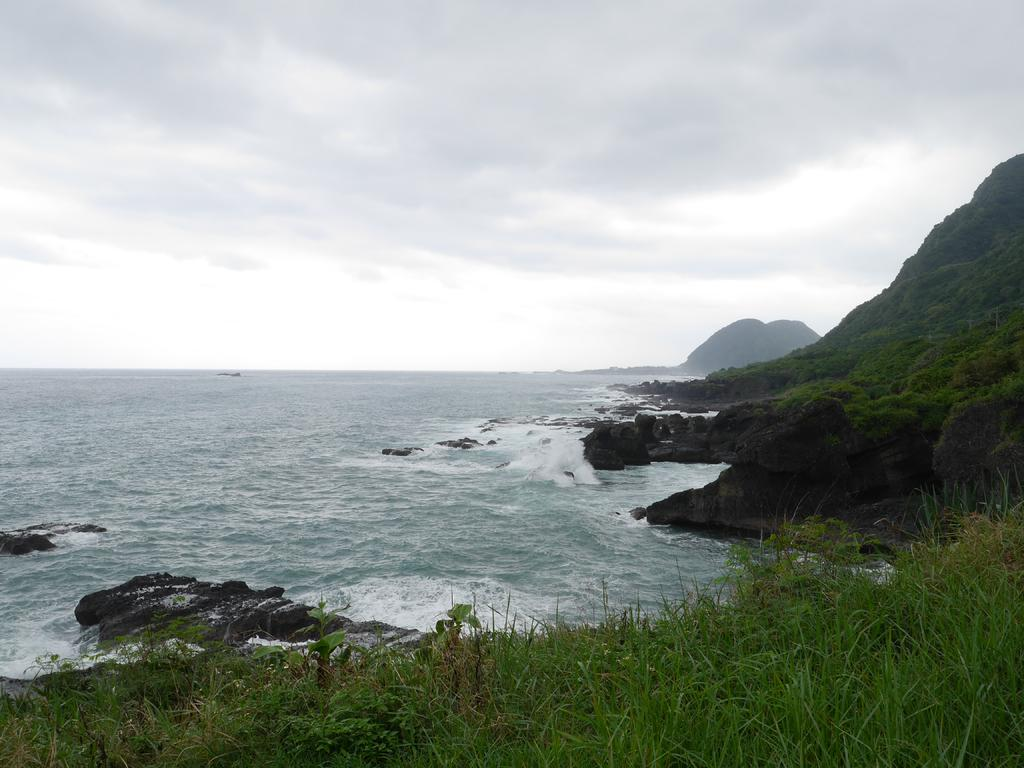What is one of the natural elements present in the image? There is water in the image. What type of terrain can be seen in the image? There are stones and grass in the image, as well as hills. What is visible in the background of the image? The sky is visible in the image, and clouds are present in the sky. What type of company is conducting a meeting in the image? There is no company or meeting present in the image; it features natural elements such as water, stones, grass, hills, and the sky. Can you tell me how many pickles are resting on the grass in the image? There are no pickles present in the image; it features natural elements such as water, stones, grass, hills, and the sky. 